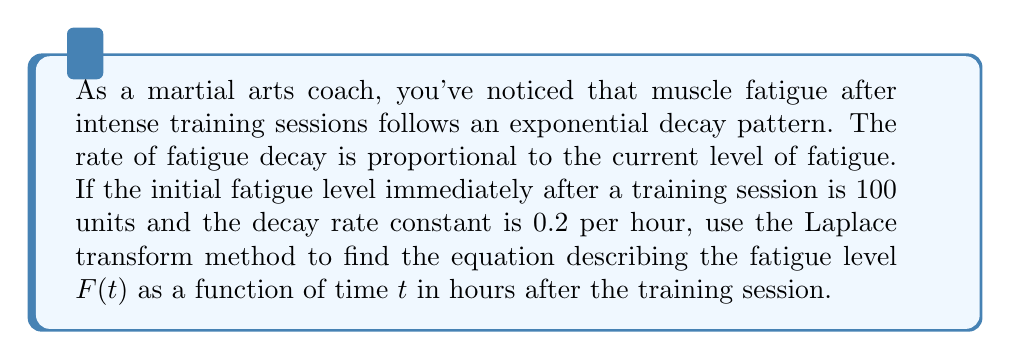Give your solution to this math problem. Let's approach this problem step-by-step using the Laplace transform method:

1) The differential equation describing the fatigue decay is:

   $$\frac{dF}{dt} = -0.2F$$

   with the initial condition $F(0) = 100$.

2) Let's take the Laplace transform of both sides. We'll use $s$ as the Laplace variable and $\mathcal{L}\{F(t)\} = \bar{F}(s)$:

   $$\mathcal{L}\{\frac{dF}{dt}\} = \mathcal{L}\{-0.2F\}$$

3) Using the Laplace transform property for derivatives:

   $$s\bar{F}(s) - F(0) = -0.2\bar{F}(s)$$

4) Substitute the initial condition $F(0) = 100$:

   $$s\bar{F}(s) - 100 = -0.2\bar{F}(s)$$

5) Rearrange the equation:

   $$s\bar{F}(s) + 0.2\bar{F}(s) = 100$$
   $$(s + 0.2)\bar{F}(s) = 100$$

6) Solve for $\bar{F}(s)$:

   $$\bar{F}(s) = \frac{100}{s + 0.2}$$

7) This is in the form of a known Laplace transform pair. The inverse Laplace transform is:

   $$F(t) = 100e^{-0.2t}$$

This equation describes the fatigue level as a function of time after the training session.
Answer: $F(t) = 100e^{-0.2t}$, where $F(t)$ is the fatigue level and $t$ is time in hours after the training session. 